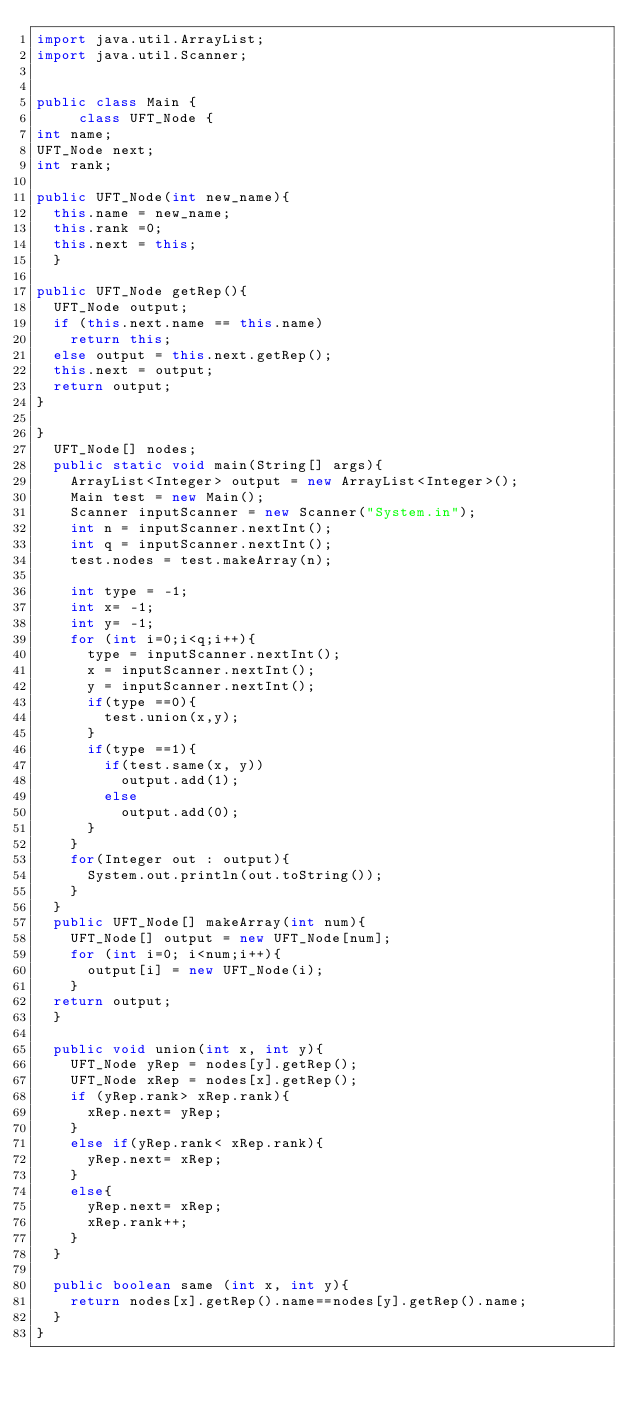<code> <loc_0><loc_0><loc_500><loc_500><_Java_>import java.util.ArrayList;
import java.util.Scanner;


public class Main {
     class UFT_Node {
int name;
UFT_Node next;
int rank;

public UFT_Node(int new_name){
	this.name = new_name;
	this.rank =0;
	this.next = this;
	}

public UFT_Node getRep(){
	UFT_Node output;
	if (this.next.name == this.name)
		return this;
	else output = this.next.getRep();
	this.next = output; 
	return output;
}

}
	UFT_Node[] nodes;
	public static void main(String[] args){
		ArrayList<Integer> output = new ArrayList<Integer>();
		Main test = new Main();
		Scanner inputScanner = new Scanner("System.in");
		int n = inputScanner.nextInt();
		int q = inputScanner.nextInt();
		test.nodes = test.makeArray(n);
		
		int type = -1;
		int x= -1;
		int y= -1;
		for (int i=0;i<q;i++){
			type = inputScanner.nextInt();
			x = inputScanner.nextInt();
			y = inputScanner.nextInt();
			if(type ==0){
				test.union(x,y);
			}
			if(type ==1){
				if(test.same(x, y))
					output.add(1);
				else
					output.add(0);
			}
		} 
		for(Integer out : output){
			System.out.println(out.toString());
		}
	}
	public UFT_Node[] makeArray(int num){
		UFT_Node[] output = new UFT_Node[num];
		for (int i=0; i<num;i++){
			output[i] = new UFT_Node(i);
		}
	return output;
	}
	
	public void union(int x, int y){
		UFT_Node yRep = nodes[y].getRep();
		UFT_Node xRep = nodes[x].getRep();
		if (yRep.rank> xRep.rank){
			xRep.next= yRep;
		}
		else if(yRep.rank< xRep.rank){
			yRep.next= xRep;
		}
		else{
			yRep.next= xRep;
			xRep.rank++;
		}
	}
	
	public boolean same (int x, int y){
		return nodes[x].getRep().name==nodes[y].getRep().name;
	}
}

</code> 